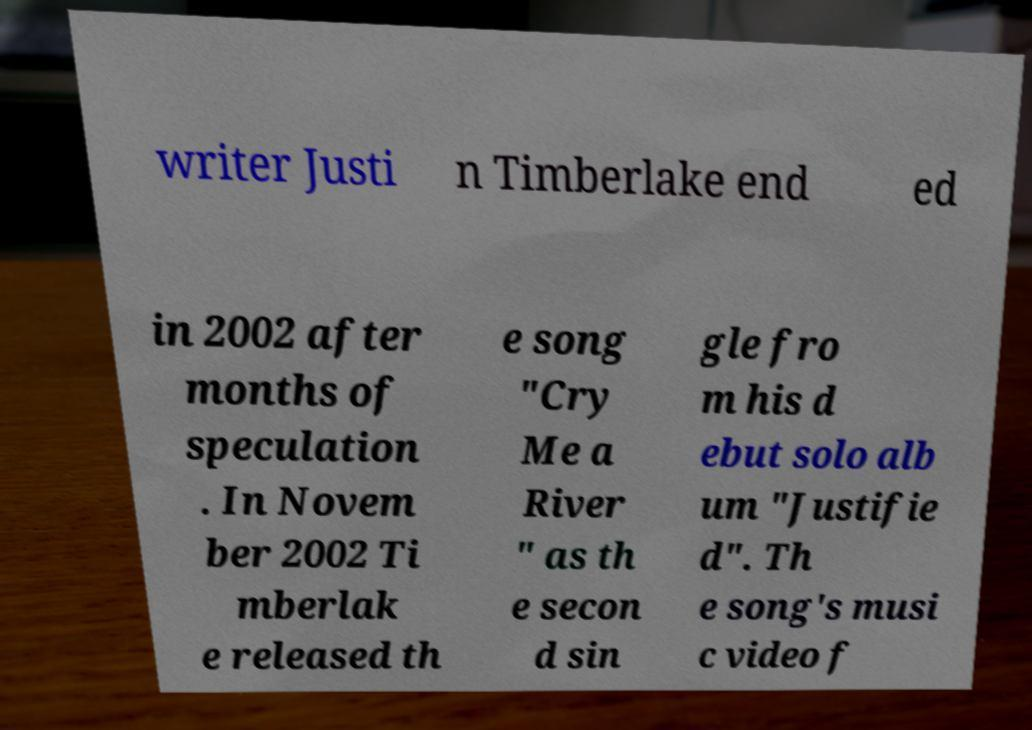Could you extract and type out the text from this image? writer Justi n Timberlake end ed in 2002 after months of speculation . In Novem ber 2002 Ti mberlak e released th e song "Cry Me a River " as th e secon d sin gle fro m his d ebut solo alb um "Justifie d". Th e song's musi c video f 